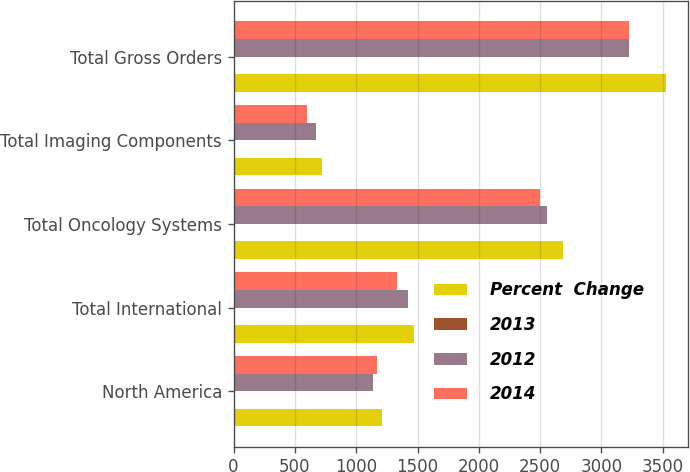Convert chart to OTSL. <chart><loc_0><loc_0><loc_500><loc_500><stacked_bar_chart><ecel><fcel>North America<fcel>Total International<fcel>Total Oncology Systems<fcel>Total Imaging Components<fcel>Total Gross Orders<nl><fcel>Percent  Change<fcel>1214.4<fcel>1470<fcel>2684.4<fcel>722.5<fcel>3527.3<nl><fcel>2013<fcel>7<fcel>4<fcel>5<fcel>8<fcel>9<nl><fcel>2012<fcel>1135.3<fcel>1418.8<fcel>2554.1<fcel>668.2<fcel>3224.8<nl><fcel>2014<fcel>1167.1<fcel>1333.3<fcel>2500.4<fcel>596.3<fcel>3223<nl></chart> 